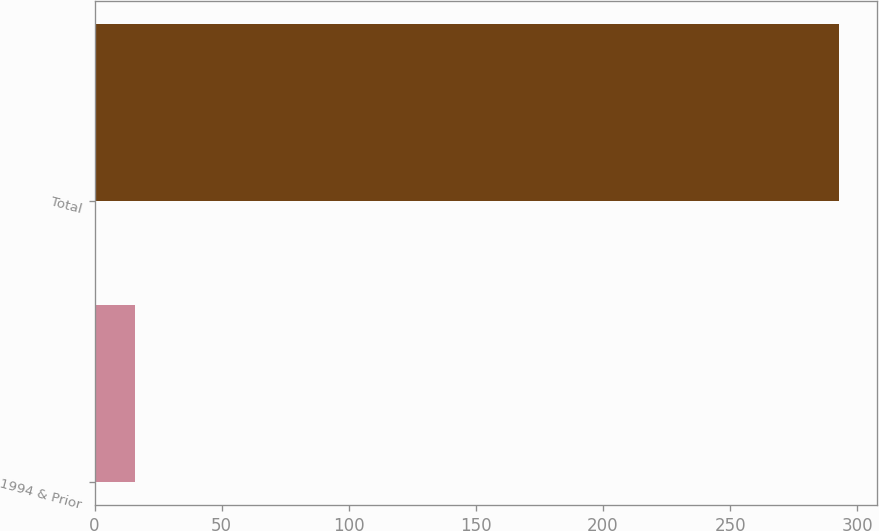Convert chart to OTSL. <chart><loc_0><loc_0><loc_500><loc_500><bar_chart><fcel>1994 & Prior<fcel>Total<nl><fcel>16<fcel>293<nl></chart> 